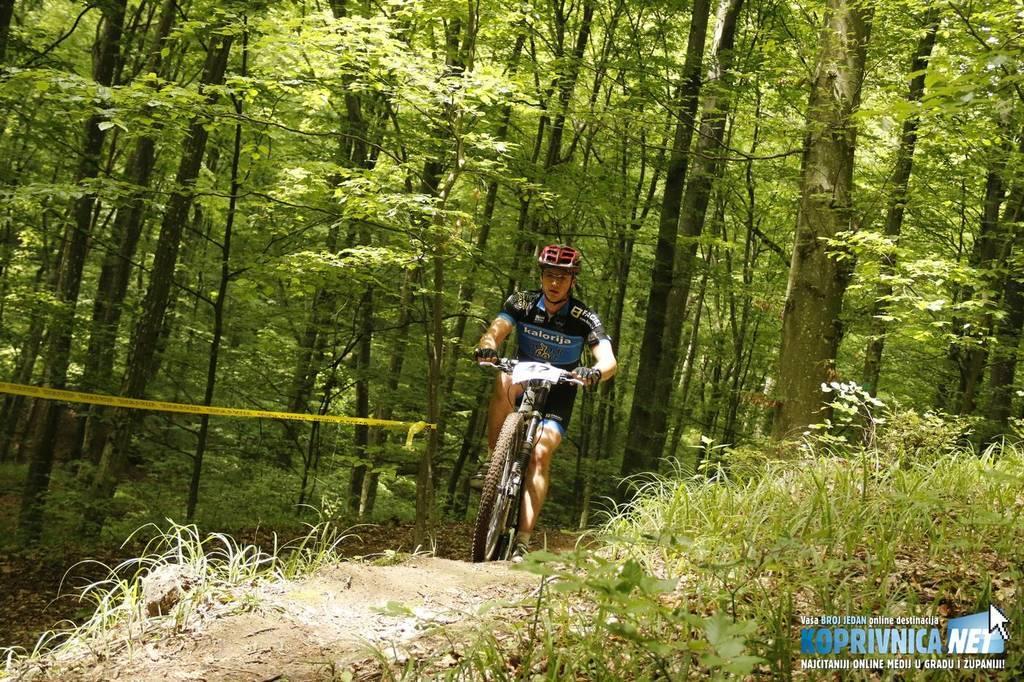Could you give a brief overview of what you see in this image? In the middle of the image I can see a person is riding a bicycle and wore helmet. In the front of the image there are plants, grass and rock. In the background of the image there are trees, plants and ribbon. At the bottom right side of the image there is a watermark. 